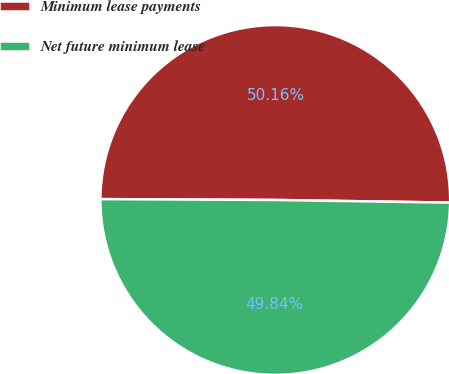Convert chart to OTSL. <chart><loc_0><loc_0><loc_500><loc_500><pie_chart><fcel>Minimum lease payments<fcel>Net future minimum lease<nl><fcel>50.16%<fcel>49.84%<nl></chart> 